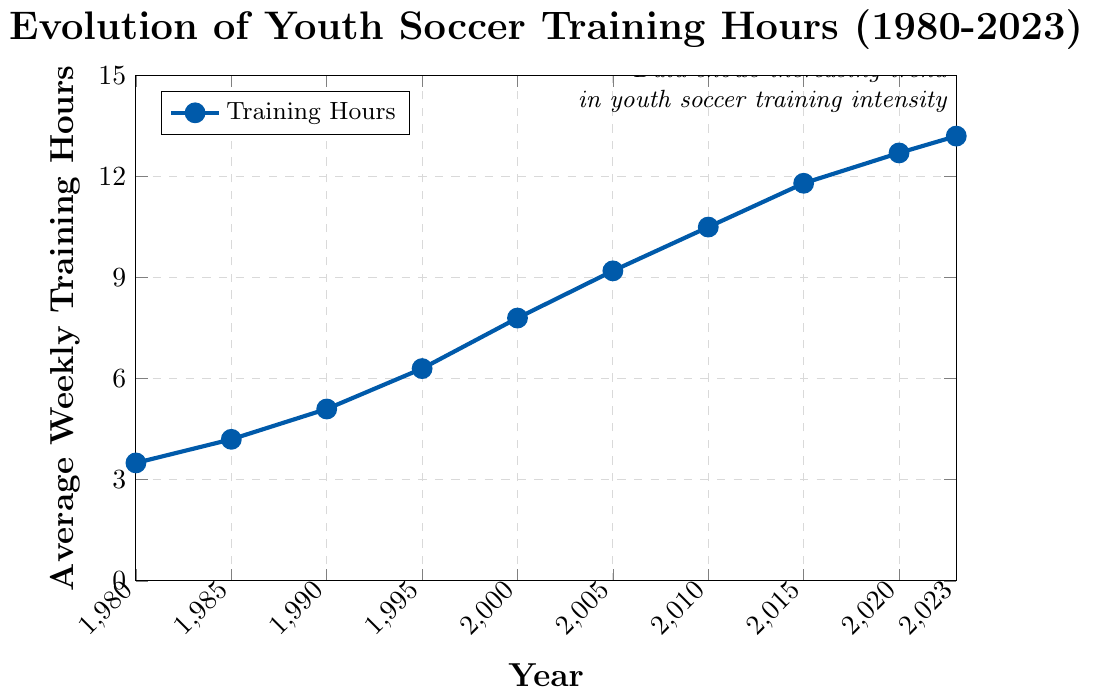What is the average weekly training hours in 1990? To find the average weekly training hours in 1990, look at the y-axis corresponding to the year 1990 on the x-axis. The point indicates that the average weekly training hours were 5.1 in 1990.
Answer: 5.1 Which year shows the highest average weekly training hours? To determine the year with the highest average weekly training hours, inspect the graph for the highest point. The highest point corresponds to the year 2023, with 13.2 hours.
Answer: 2023 How much did the average weekly training hours increase from 1980 to 2023? To calculate the increase, subtract the average weekly training hours in 1980 (3.5) from the 2023 value (13.2). The increase is 13.2 - 3.5 = 9.7 hours.
Answer: 9.7 hours In which period did the average weekly training hours increase the fastest? To identify the period of the fastest increase, compare the steepness of the slopes between consecutive points. The steepest slope appears between 1990 and 2000, increasing from 5.1 to 7.8 hours, a difference of 2.7 hours over 10 years.
Answer: 1990-2000 By how much did the average weekly training hours change from 2010 to 2015? To find the change from 2010 to 2015, subtract the value in 2010 (10.5) from the value in 2015 (11.8). The change is 11.8 - 10.5 = 1.3 hours.
Answer: 1.3 hours What is the trend shown by the data? By analyzing the graph, it is clear that there is a consistent upward trend in the average weekly training hours for youth soccer players from 1980 to 2023.
Answer: Upward trend What is the percentage increase in average weekly training hours from 1985 to 2000? To find the percentage increase, use the formula: ((new value - old value) / old value) * 100. With values from 1985 (4.2 hours) to 2000 (7.8 hours): ((7.8 - 4.2) / 4.2) * 100 ≈ 85.7%.
Answer: 85.7% During which two consecutive years was the smallest increase in average weekly training hours recorded? To find the smallest increase, compare the differences between consecutive years. The smallest increase is from 2020 to 2023 (12.7 to 13.2 hours), a difference of 0.5 hours.
Answer: 2020-2023 How does the training intensity in 2010 compare to 1980? To compare, examine the values in 2010 (10.5 hours) and 1980 (3.5 hours). The training intensity in 2010 is three times higher than in 1980.
Answer: Three times higher 